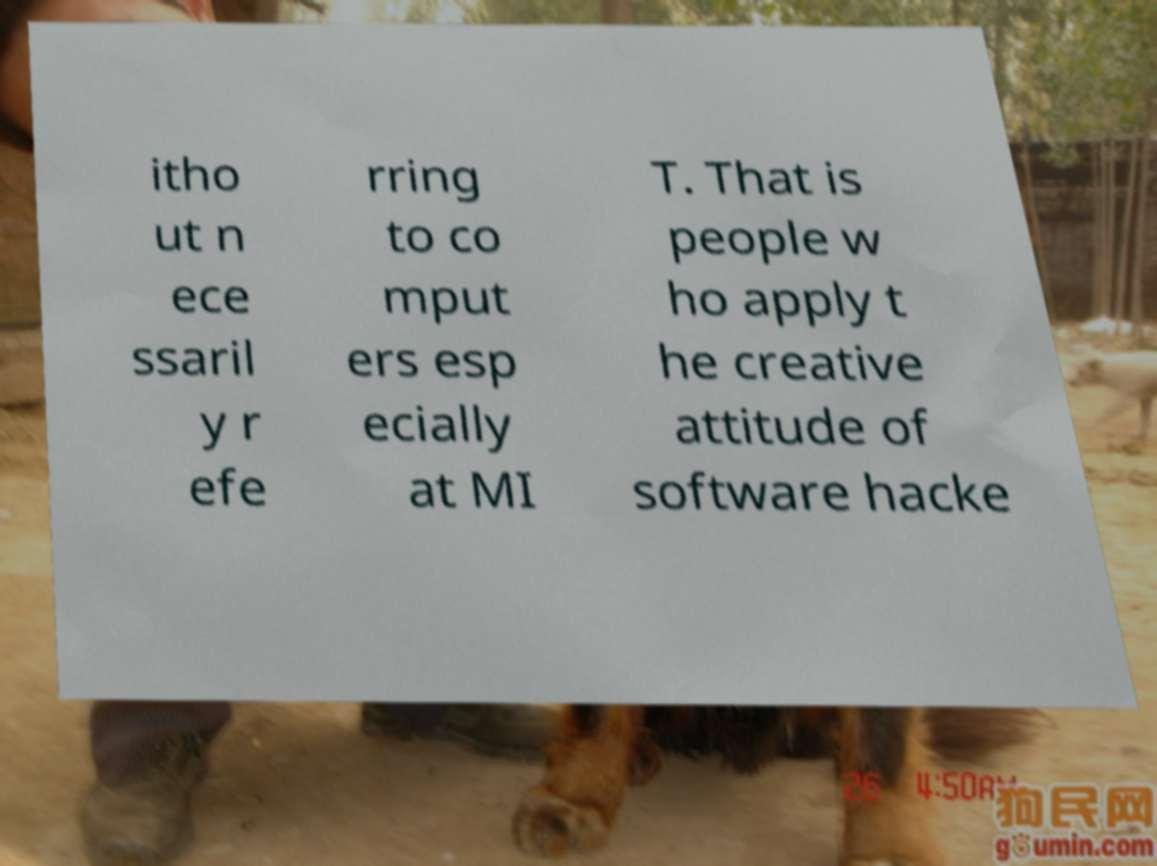There's text embedded in this image that I need extracted. Can you transcribe it verbatim? itho ut n ece ssaril y r efe rring to co mput ers esp ecially at MI T. That is people w ho apply t he creative attitude of software hacke 